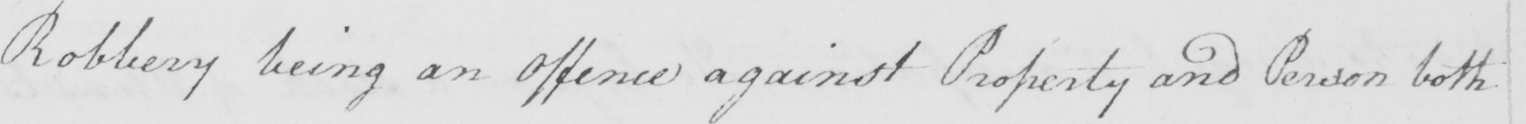Please provide the text content of this handwritten line. Robbery being an Offence against Property and Person both 